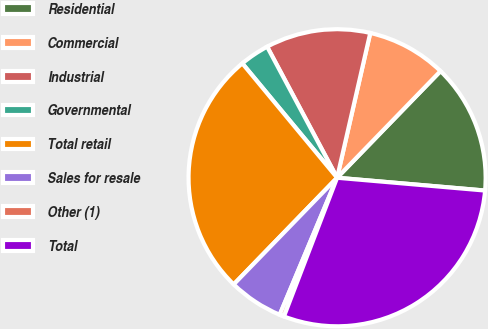<chart> <loc_0><loc_0><loc_500><loc_500><pie_chart><fcel>Residential<fcel>Commercial<fcel>Industrial<fcel>Governmental<fcel>Total retail<fcel>Sales for resale<fcel>Other (1)<fcel>Total<nl><fcel>14.12%<fcel>8.67%<fcel>11.39%<fcel>3.21%<fcel>26.73%<fcel>5.94%<fcel>0.49%<fcel>29.45%<nl></chart> 